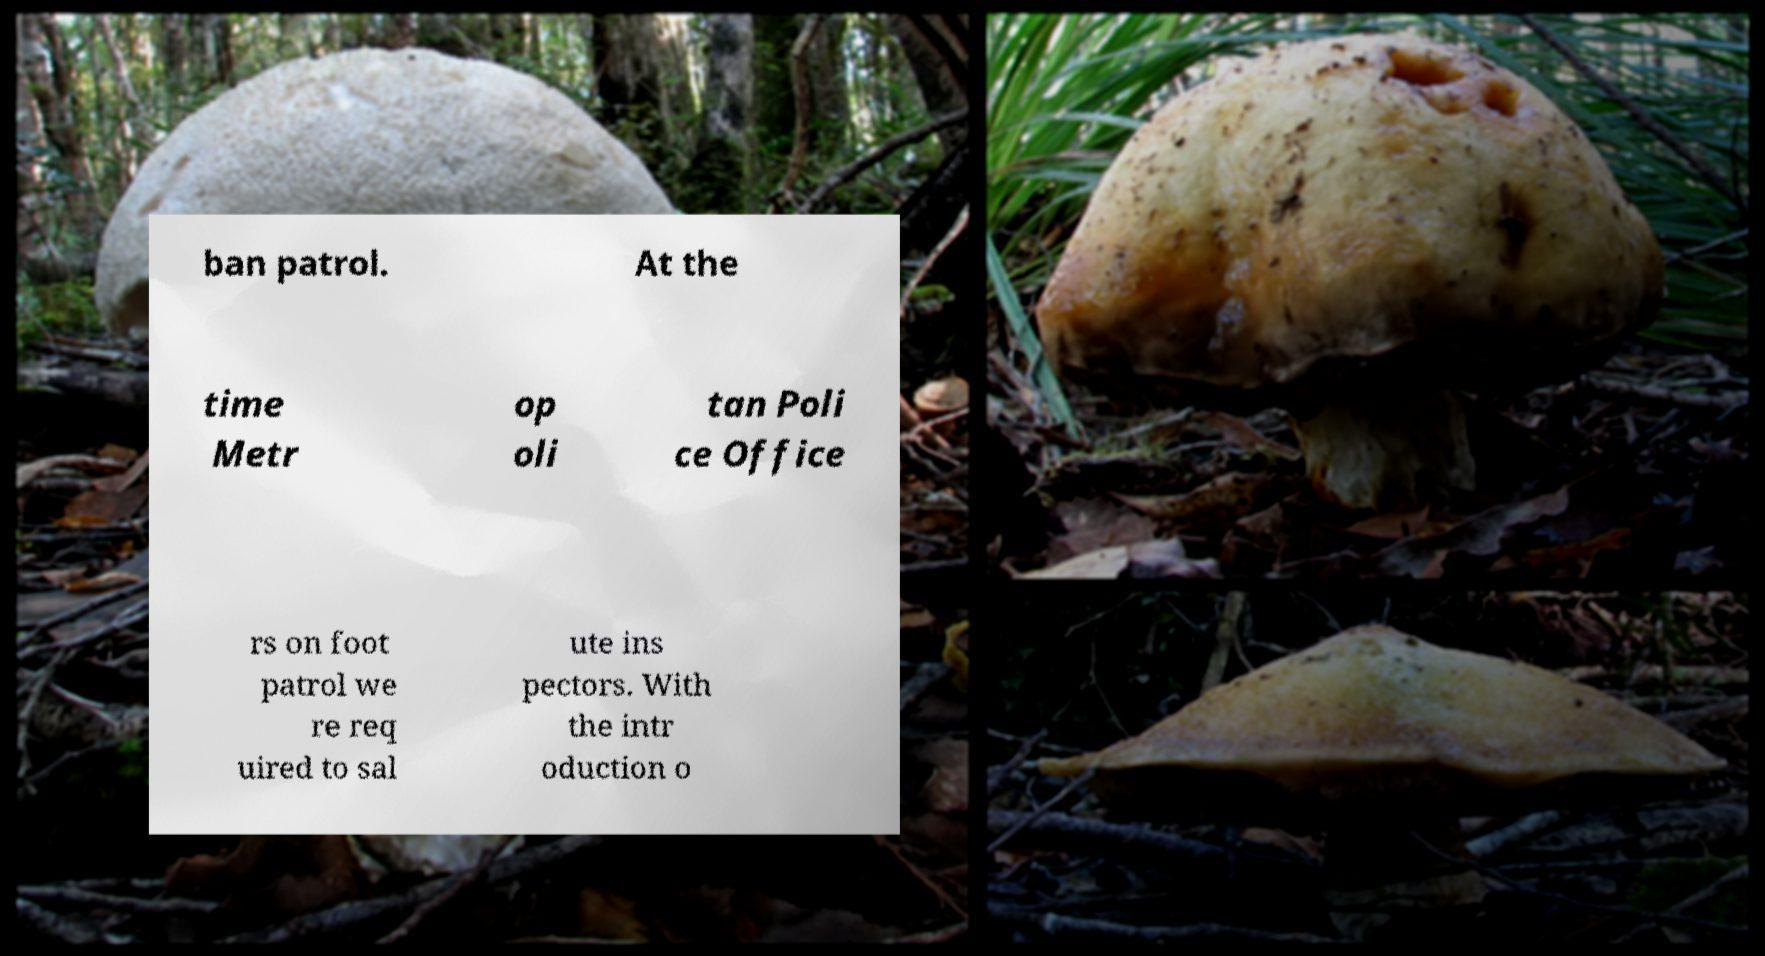For documentation purposes, I need the text within this image transcribed. Could you provide that? ban patrol. At the time Metr op oli tan Poli ce Office rs on foot patrol we re req uired to sal ute ins pectors. With the intr oduction o 